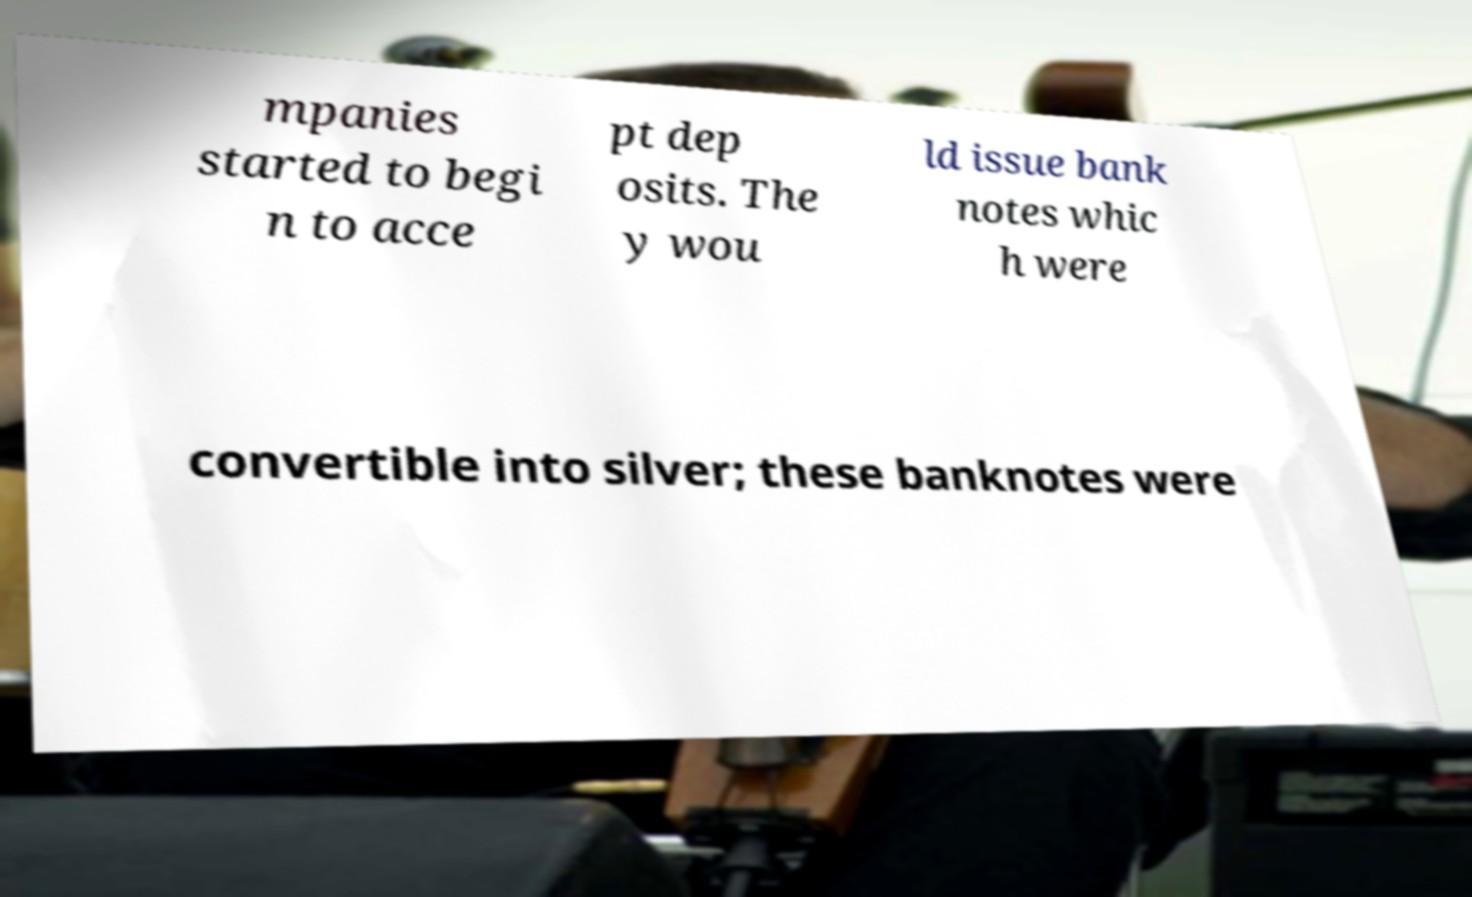Please identify and transcribe the text found in this image. mpanies started to begi n to acce pt dep osits. The y wou ld issue bank notes whic h were convertible into silver; these banknotes were 